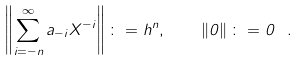Convert formula to latex. <formula><loc_0><loc_0><loc_500><loc_500>\left \| \sum _ { i = - n } ^ { \infty } a _ { - i } X ^ { - i } \right \| \colon = h ^ { n } , \quad \left \| 0 \right \| \colon = 0 \ .</formula> 